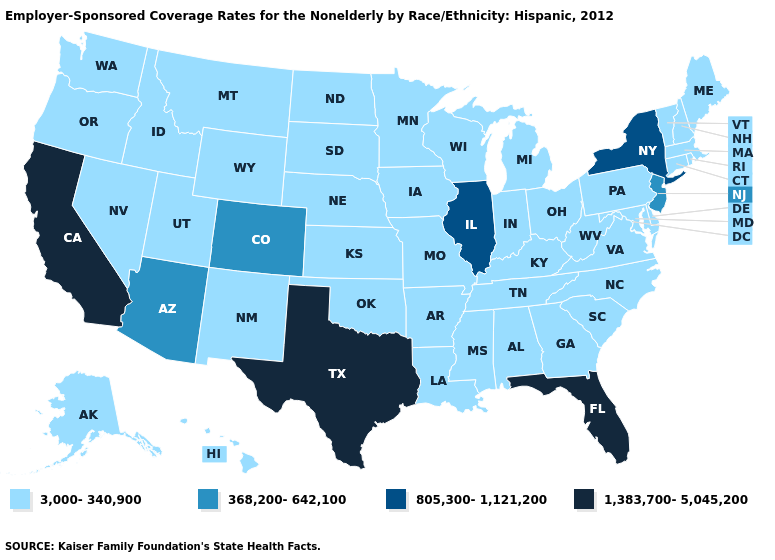Among the states that border Mississippi , which have the lowest value?
Concise answer only. Alabama, Arkansas, Louisiana, Tennessee. What is the value of New Jersey?
Be succinct. 368,200-642,100. Name the states that have a value in the range 368,200-642,100?
Keep it brief. Arizona, Colorado, New Jersey. Among the states that border Minnesota , which have the lowest value?
Short answer required. Iowa, North Dakota, South Dakota, Wisconsin. What is the value of North Carolina?
Short answer required. 3,000-340,900. Does North Carolina have the same value as Texas?
Short answer required. No. Which states have the highest value in the USA?
Be succinct. California, Florida, Texas. What is the highest value in the MidWest ?
Keep it brief. 805,300-1,121,200. What is the highest value in the South ?
Keep it brief. 1,383,700-5,045,200. What is the highest value in the USA?
Concise answer only. 1,383,700-5,045,200. Does the map have missing data?
Be succinct. No. Name the states that have a value in the range 368,200-642,100?
Quick response, please. Arizona, Colorado, New Jersey. What is the value of Massachusetts?
Answer briefly. 3,000-340,900. Does Kentucky have the lowest value in the South?
Keep it brief. Yes. Does Massachusetts have the highest value in the Northeast?
Be succinct. No. 